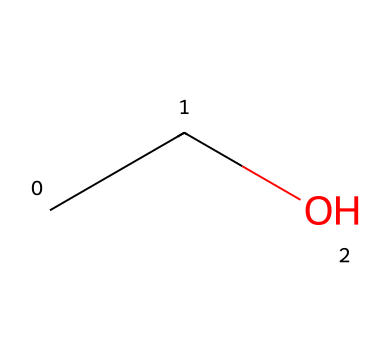What is the name of this chemical? The SMILES representation "CCO" corresponds to ethanol, which is commonly used in alcoholic beverages.
Answer: ethanol How many carbon atoms are present in this chemical? The representation "CCO" indicates there are two "C" symbols, which represent two carbon atoms in the structure of ethanol.
Answer: 2 What type of bonds are found in this chemical? The structure contains single bonds between the carbon atoms and between carbon and oxygen, typical for ethanol which is a simple alcohol.
Answer: single bonds What functional group is present in this chemical? The "O" in "CCO" indicates that there is a hydroxyl (-OH) group, which signifies that this is an alcohol, specifically ethanol.
Answer: hydroxyl group What is the molecular formula of this compound? To derive the molecular formula, we count the atoms in "CCO": there are 2 carbon, 6 hydrogen (each carbon is bonded to sufficient hydrogen to complete tetravalency), and 1 oxygen, resulting in C2H6O.
Answer: C2H6O Does this chemical contribute to the intoxicating effects found in beverages? Ethanol is a psychoactive substance and is responsible for the intoxicating effects in alcoholic beverages.
Answer: yes What is the boiling point range of this chemical compared to water? Ethanol has a boiling point of about 78 degrees Celsius, which is lower than water's boiling point of 100 degrees Celsius, indicating it evaporates more readily.
Answer: lower 